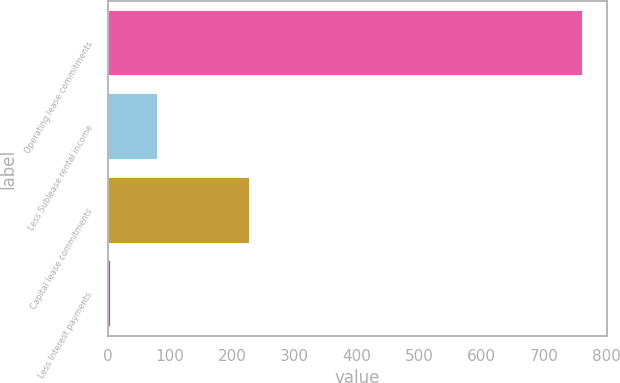Convert chart. <chart><loc_0><loc_0><loc_500><loc_500><bar_chart><fcel>Operating lease commitments<fcel>Less Sublease rental income<fcel>Capital lease commitments<fcel>Less Interest payments<nl><fcel>763<fcel>80.8<fcel>229<fcel>5<nl></chart> 